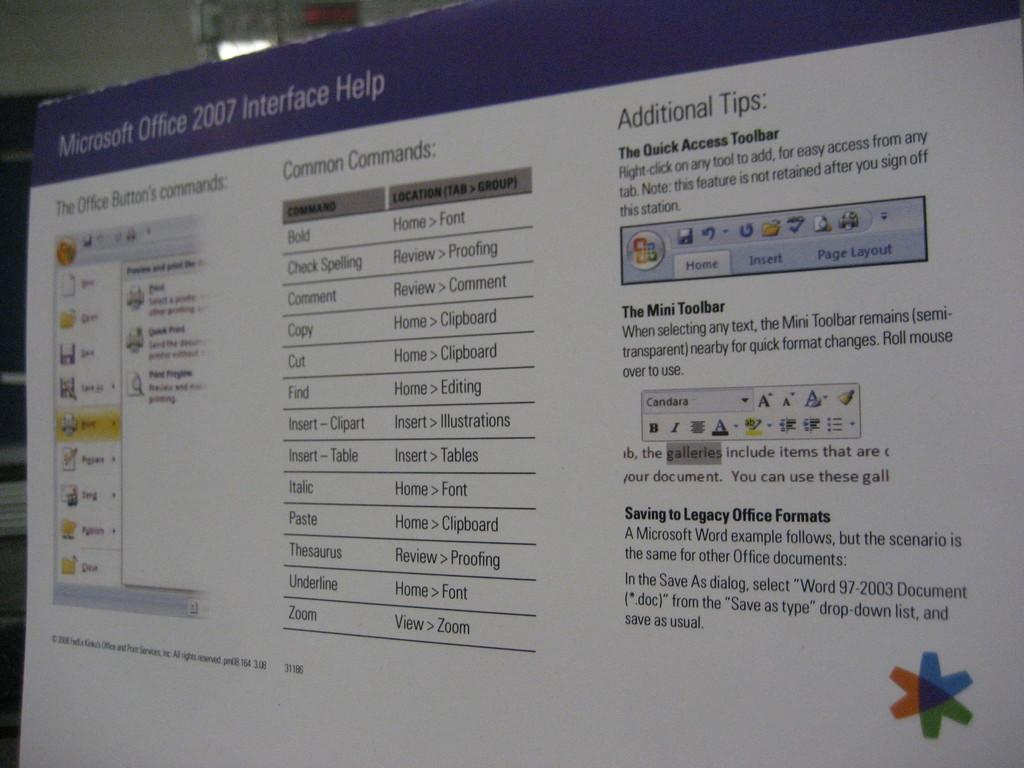Provide a one-sentence caption for the provided image. The screen is from Microsoft Office 2007 and is a help screen. 